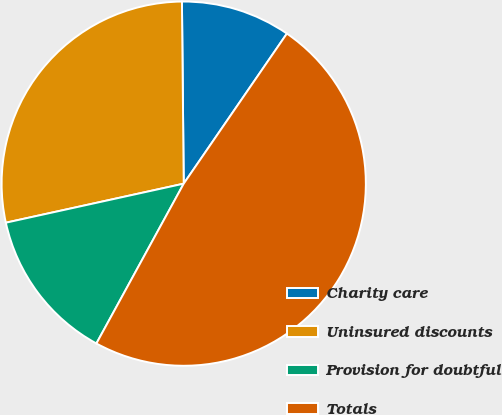Convert chart to OTSL. <chart><loc_0><loc_0><loc_500><loc_500><pie_chart><fcel>Charity care<fcel>Uninsured discounts<fcel>Provision for doubtful<fcel>Totals<nl><fcel>9.74%<fcel>28.28%<fcel>13.6%<fcel>48.37%<nl></chart> 